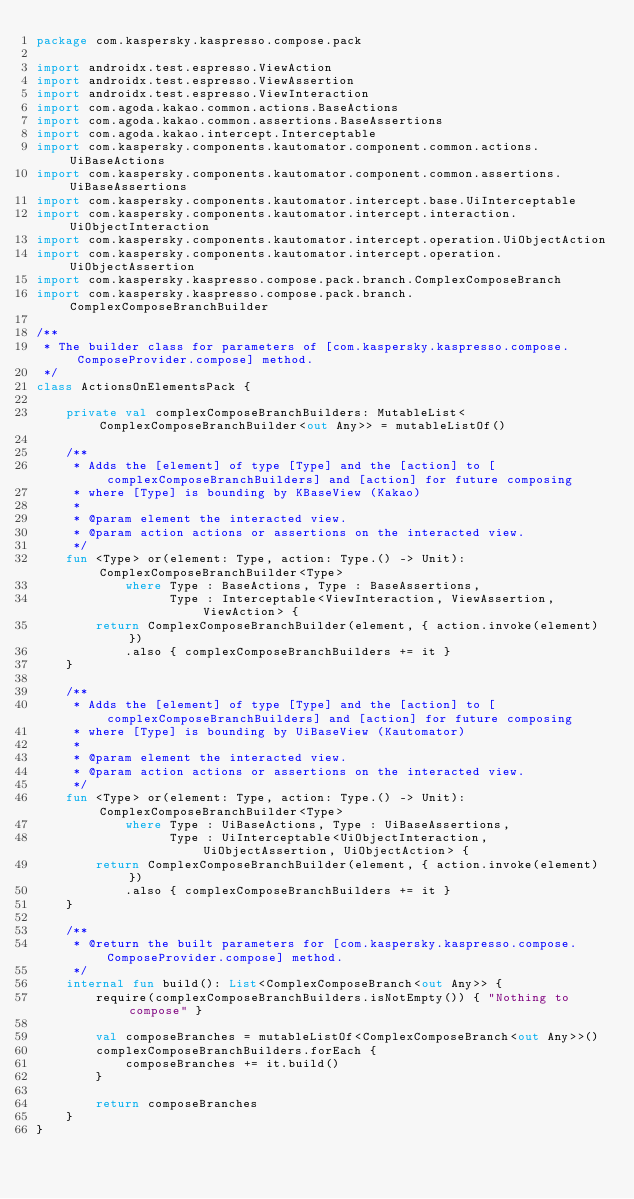<code> <loc_0><loc_0><loc_500><loc_500><_Kotlin_>package com.kaspersky.kaspresso.compose.pack

import androidx.test.espresso.ViewAction
import androidx.test.espresso.ViewAssertion
import androidx.test.espresso.ViewInteraction
import com.agoda.kakao.common.actions.BaseActions
import com.agoda.kakao.common.assertions.BaseAssertions
import com.agoda.kakao.intercept.Interceptable
import com.kaspersky.components.kautomator.component.common.actions.UiBaseActions
import com.kaspersky.components.kautomator.component.common.assertions.UiBaseAssertions
import com.kaspersky.components.kautomator.intercept.base.UiInterceptable
import com.kaspersky.components.kautomator.intercept.interaction.UiObjectInteraction
import com.kaspersky.components.kautomator.intercept.operation.UiObjectAction
import com.kaspersky.components.kautomator.intercept.operation.UiObjectAssertion
import com.kaspersky.kaspresso.compose.pack.branch.ComplexComposeBranch
import com.kaspersky.kaspresso.compose.pack.branch.ComplexComposeBranchBuilder

/**
 * The builder class for parameters of [com.kaspersky.kaspresso.compose.ComposeProvider.compose] method.
 */
class ActionsOnElementsPack {

    private val complexComposeBranchBuilders: MutableList<ComplexComposeBranchBuilder<out Any>> = mutableListOf()

    /**
     * Adds the [element] of type [Type] and the [action] to [complexComposeBranchBuilders] and [action] for future composing
     * where [Type] is bounding by KBaseView (Kakao)
     *
     * @param element the interacted view.
     * @param action actions or assertions on the interacted view.
     */
    fun <Type> or(element: Type, action: Type.() -> Unit): ComplexComposeBranchBuilder<Type>
            where Type : BaseActions, Type : BaseAssertions,
                  Type : Interceptable<ViewInteraction, ViewAssertion, ViewAction> {
        return ComplexComposeBranchBuilder(element, { action.invoke(element) })
            .also { complexComposeBranchBuilders += it }
    }

    /**
     * Adds the [element] of type [Type] and the [action] to [complexComposeBranchBuilders] and [action] for future composing
     * where [Type] is bounding by UiBaseView (Kautomator)
     *
     * @param element the interacted view.
     * @param action actions or assertions on the interacted view.
     */
    fun <Type> or(element: Type, action: Type.() -> Unit): ComplexComposeBranchBuilder<Type>
            where Type : UiBaseActions, Type : UiBaseAssertions,
                  Type : UiInterceptable<UiObjectInteraction, UiObjectAssertion, UiObjectAction> {
        return ComplexComposeBranchBuilder(element, { action.invoke(element) })
            .also { complexComposeBranchBuilders += it }
    }

    /**
     * @return the built parameters for [com.kaspersky.kaspresso.compose.ComposeProvider.compose] method.
     */
    internal fun build(): List<ComplexComposeBranch<out Any>> {
        require(complexComposeBranchBuilders.isNotEmpty()) { "Nothing to compose" }

        val composeBranches = mutableListOf<ComplexComposeBranch<out Any>>()
        complexComposeBranchBuilders.forEach {
            composeBranches += it.build()
        }

        return composeBranches
    }
}
</code> 